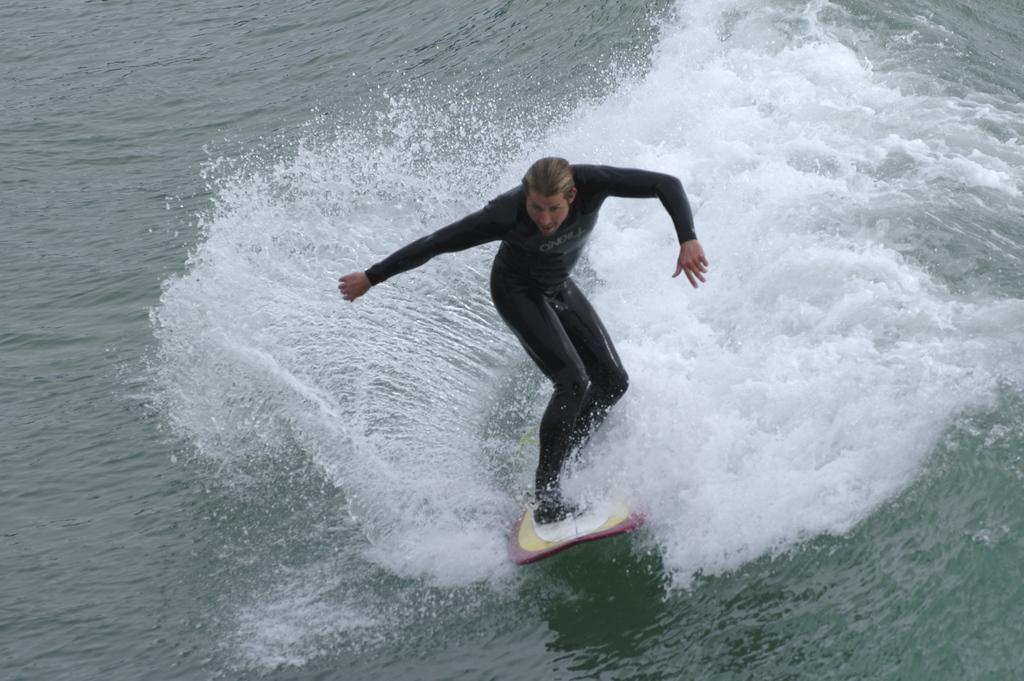Who is present in the image? There is a person in the image. What is the person wearing? The person is wearing a black dress. What activity is the person engaged in? The person is riding on a surfboard. Where is the surfboard located? The surfboard is in the ocean. Can you see any twigs or fangs in the image? No, there are no twigs or fangs present in the image. 